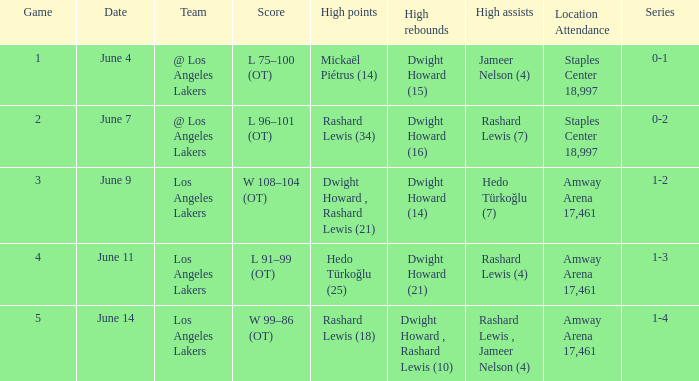What is the high points, when high rebounds is "dwight howard (16)"? Rashard Lewis (34). 